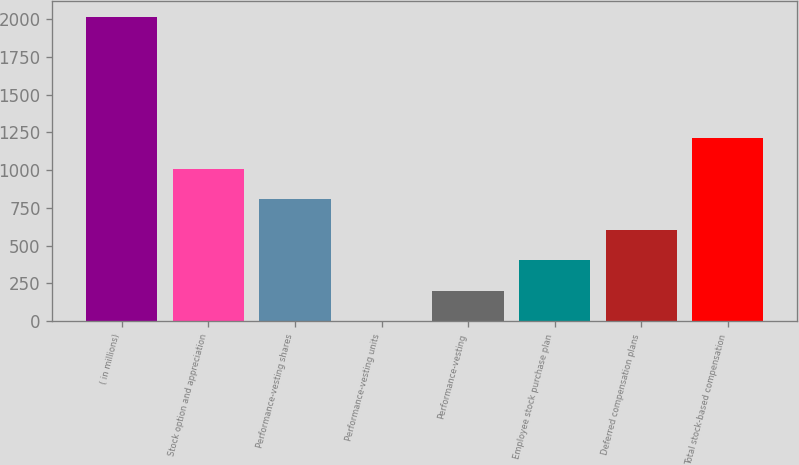Convert chart. <chart><loc_0><loc_0><loc_500><loc_500><bar_chart><fcel>( in millions)<fcel>Stock option and appreciation<fcel>Performance-vesting shares<fcel>Performance-vesting units<fcel>Performance-vesting<fcel>Employee stock purchase plan<fcel>Deferred compensation plans<fcel>Total stock-based compensation<nl><fcel>2016<fcel>1008.05<fcel>806.46<fcel>0.1<fcel>201.69<fcel>403.28<fcel>604.87<fcel>1209.64<nl></chart> 